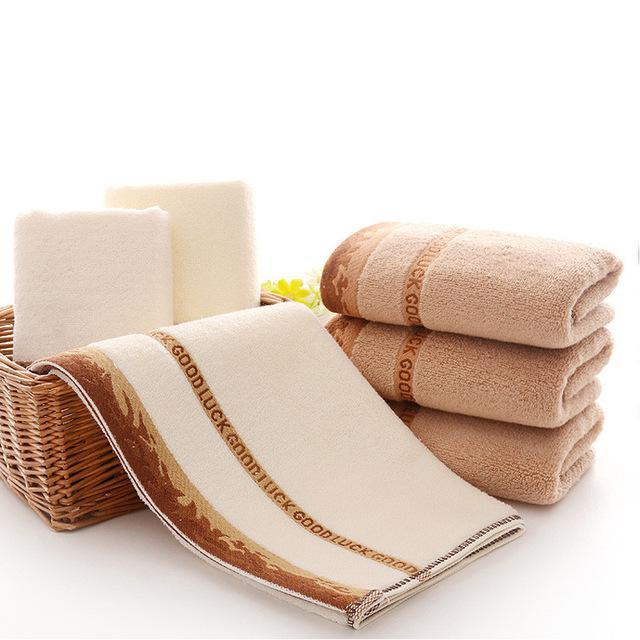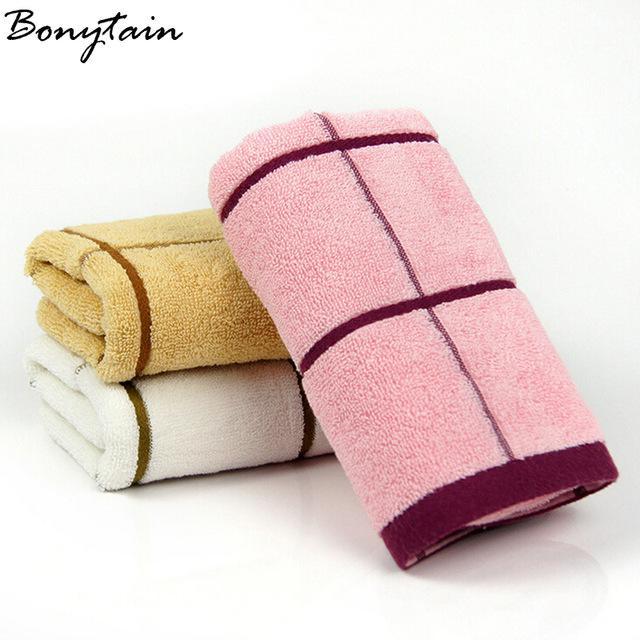The first image is the image on the left, the second image is the image on the right. Examine the images to the left and right. Is the description "There is a towel draped over a basket in one of the images." accurate? Answer yes or no. Yes. 